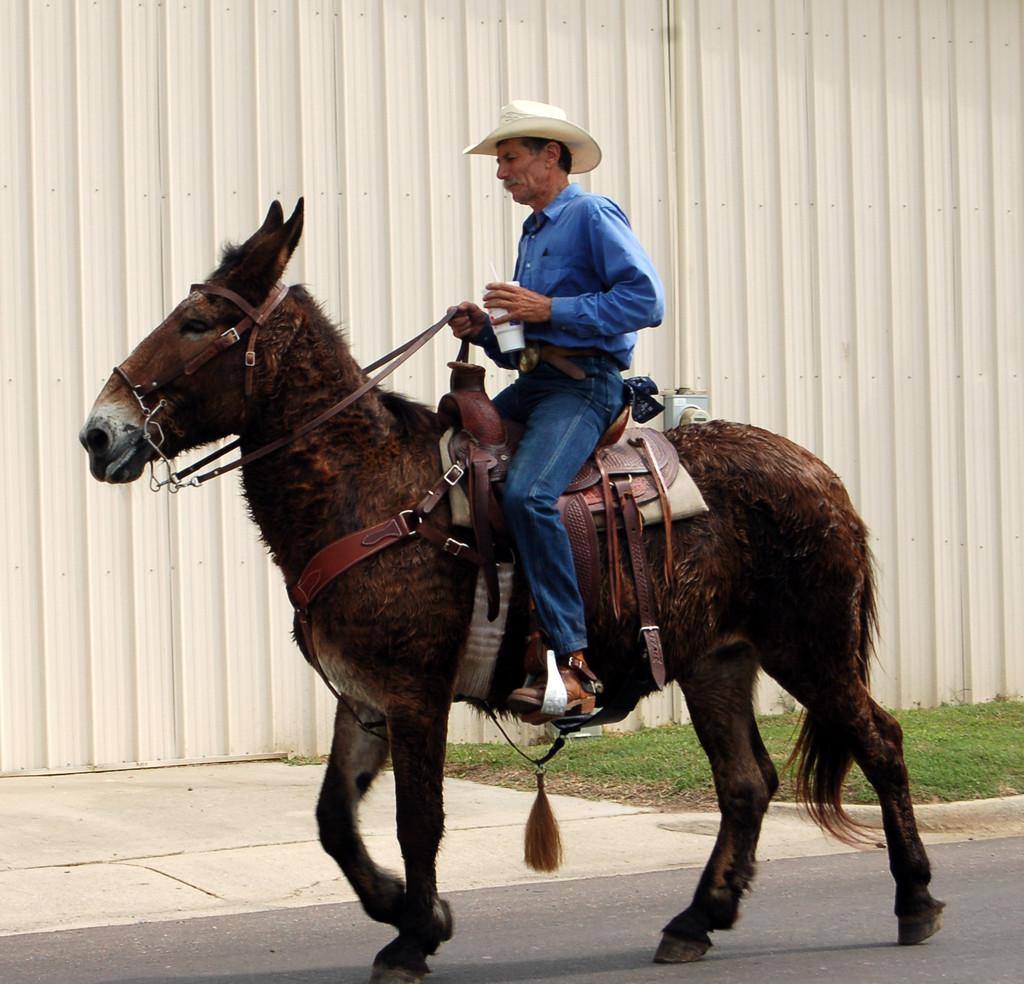Who is present in the image? There is a person in the image. What is the person doing in the image? The person is sitting on a horse and riding it. What can be seen in the background of the image? There are boards in the background of the image. What type of terrain is visible at the bottom of the image? There is grass at the bottom of the image. What architectural feature is present at the bottom of the image? There is a walkway at the bottom of the image. What flavor of pan can be seen in the image? There is no pan present in the image, and therefore no flavor can be determined. 